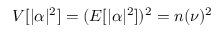<formula> <loc_0><loc_0><loc_500><loc_500>V [ | \alpha | ^ { 2 } ] = ( E [ | \alpha | ^ { 2 } ] ) ^ { 2 } = n ( \nu ) ^ { 2 }</formula> 